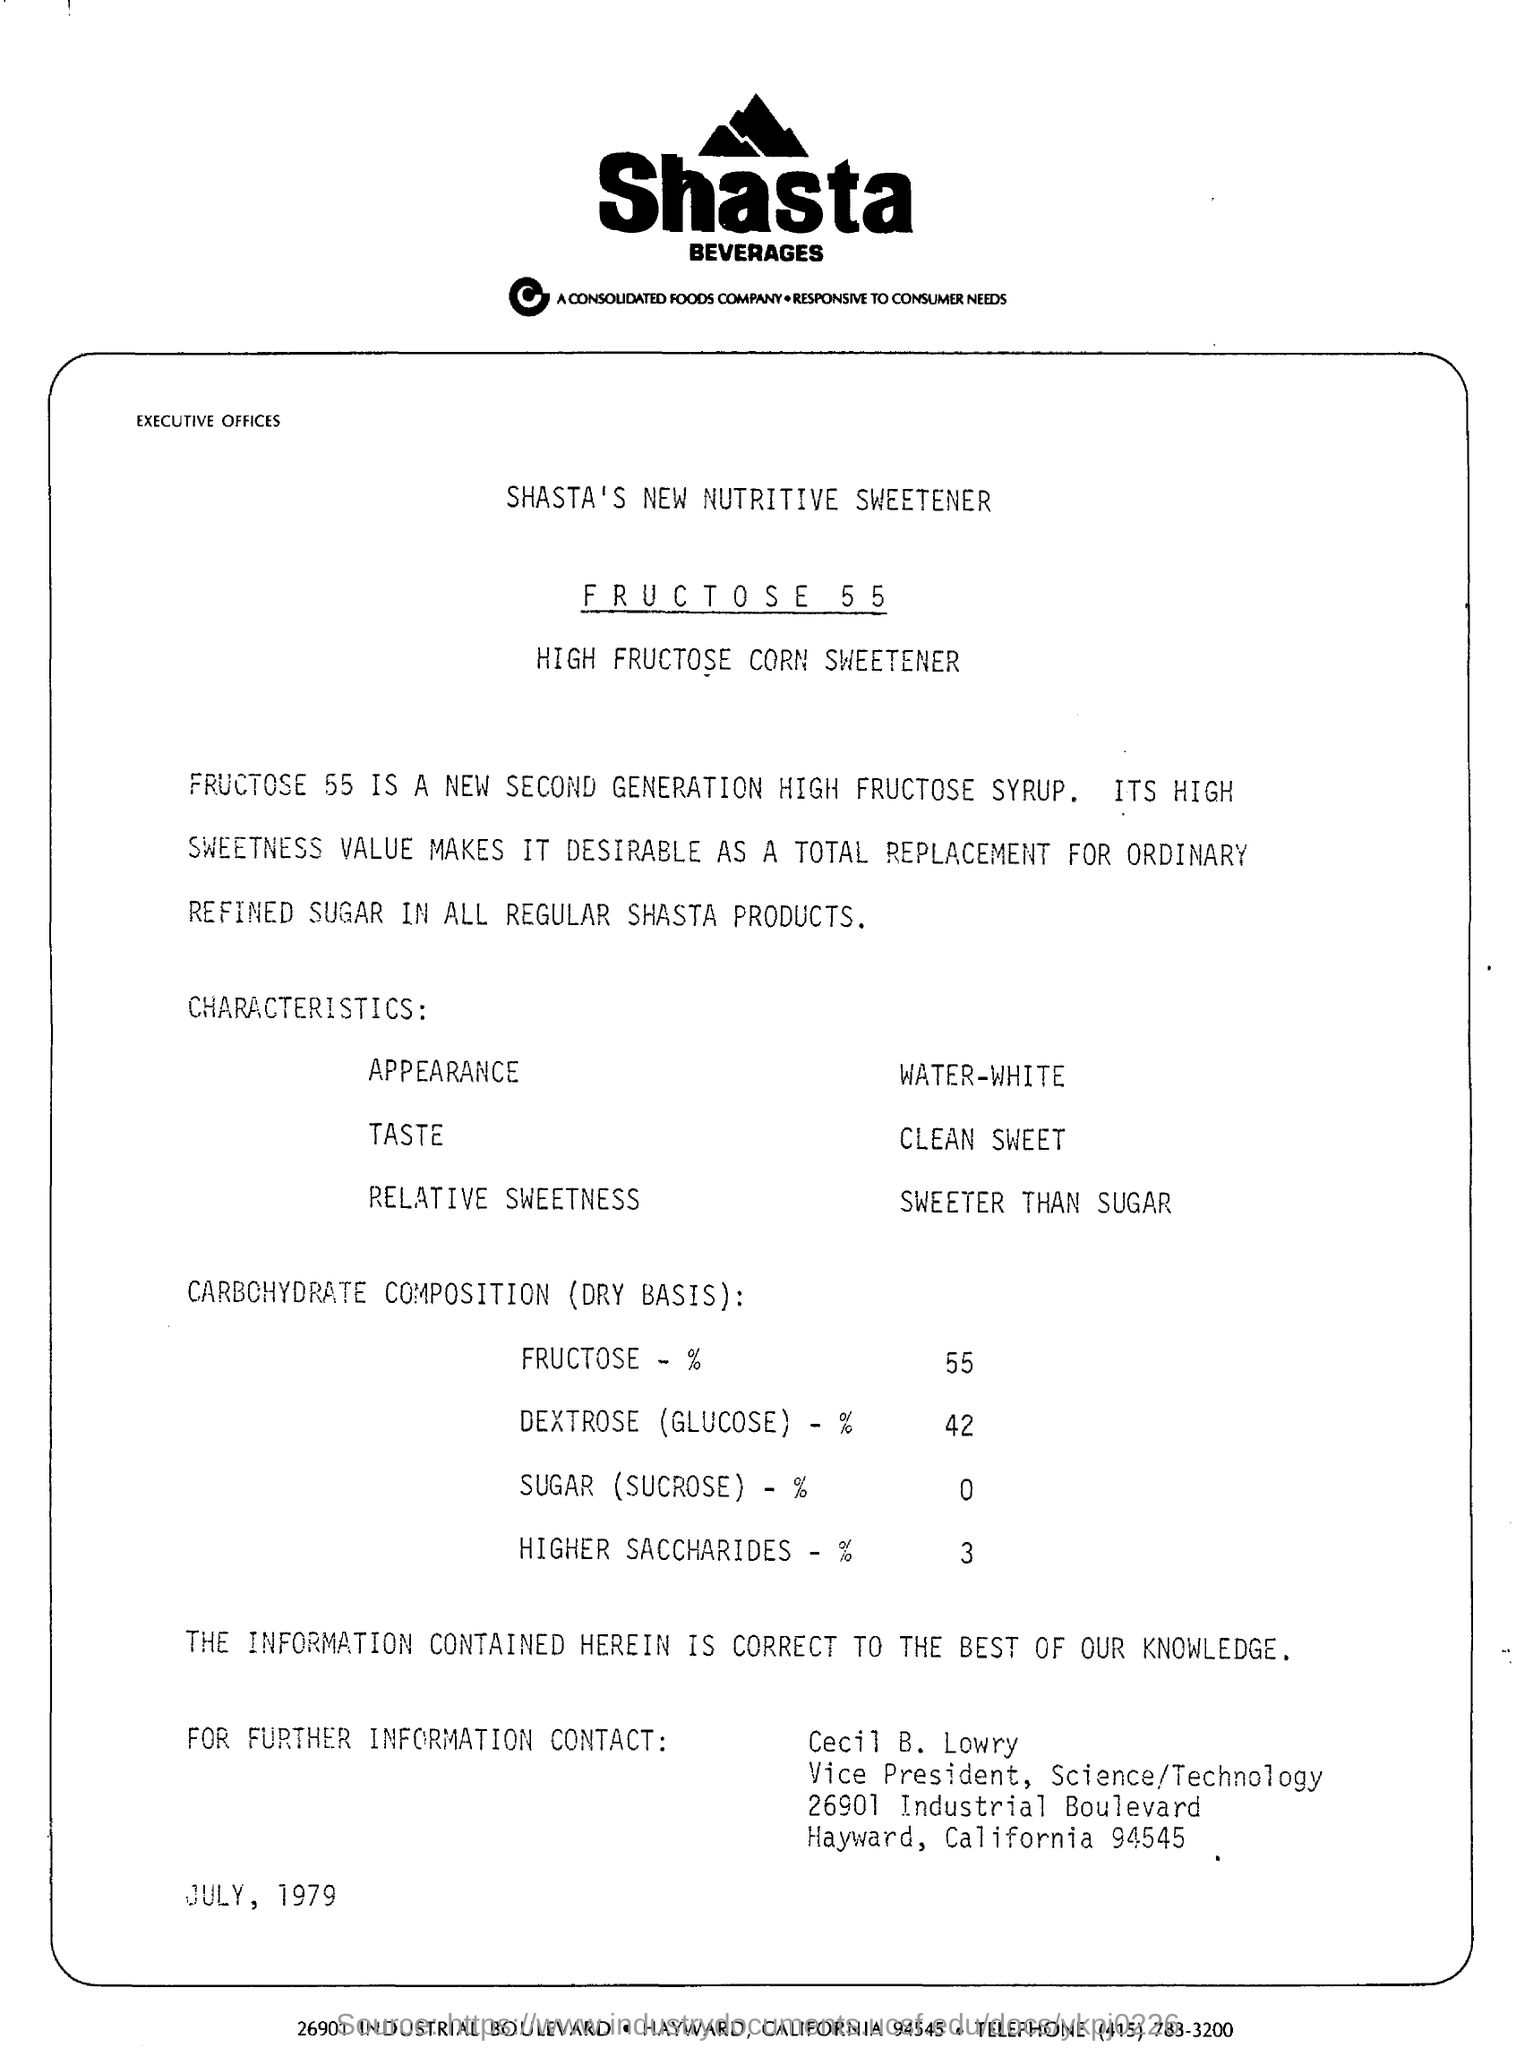Give some essential details in this illustration. The name of the beverages company is Shasta. The dextrose level is 42. FRUCTOSE 55 is the new, second generation high fructose syrup. The date mentioned is July 1979. 